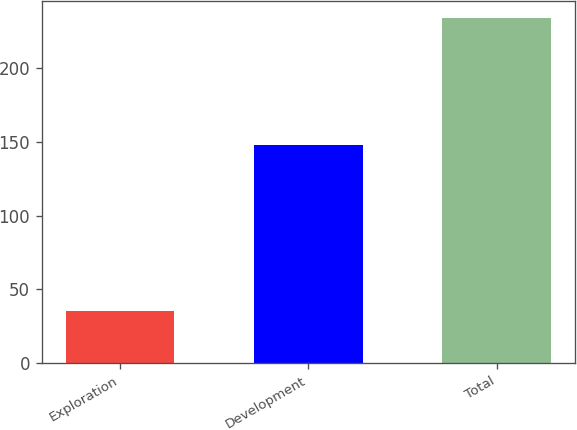<chart> <loc_0><loc_0><loc_500><loc_500><bar_chart><fcel>Exploration<fcel>Development<fcel>Total<nl><fcel>35<fcel>148<fcel>234<nl></chart> 